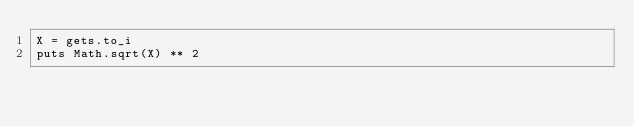<code> <loc_0><loc_0><loc_500><loc_500><_Ruby_>X = gets.to_i
puts Math.sqrt(X) ** 2</code> 